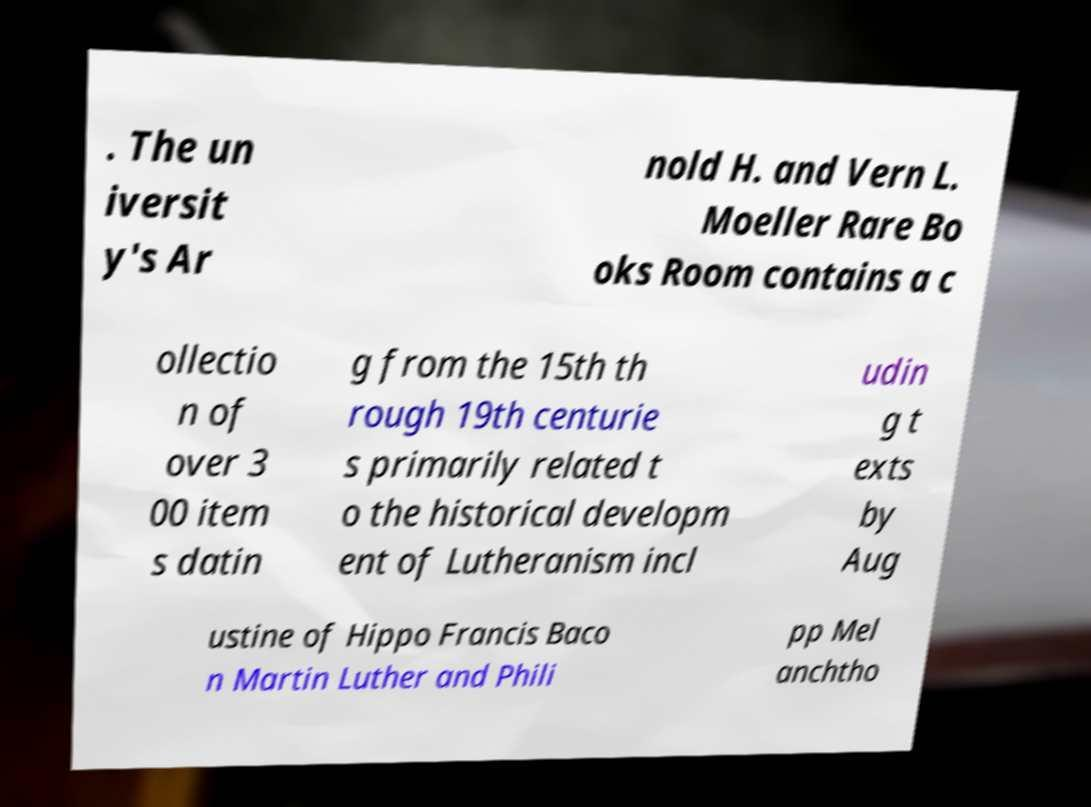For documentation purposes, I need the text within this image transcribed. Could you provide that? . The un iversit y's Ar nold H. and Vern L. Moeller Rare Bo oks Room contains a c ollectio n of over 3 00 item s datin g from the 15th th rough 19th centurie s primarily related t o the historical developm ent of Lutheranism incl udin g t exts by Aug ustine of Hippo Francis Baco n Martin Luther and Phili pp Mel anchtho 